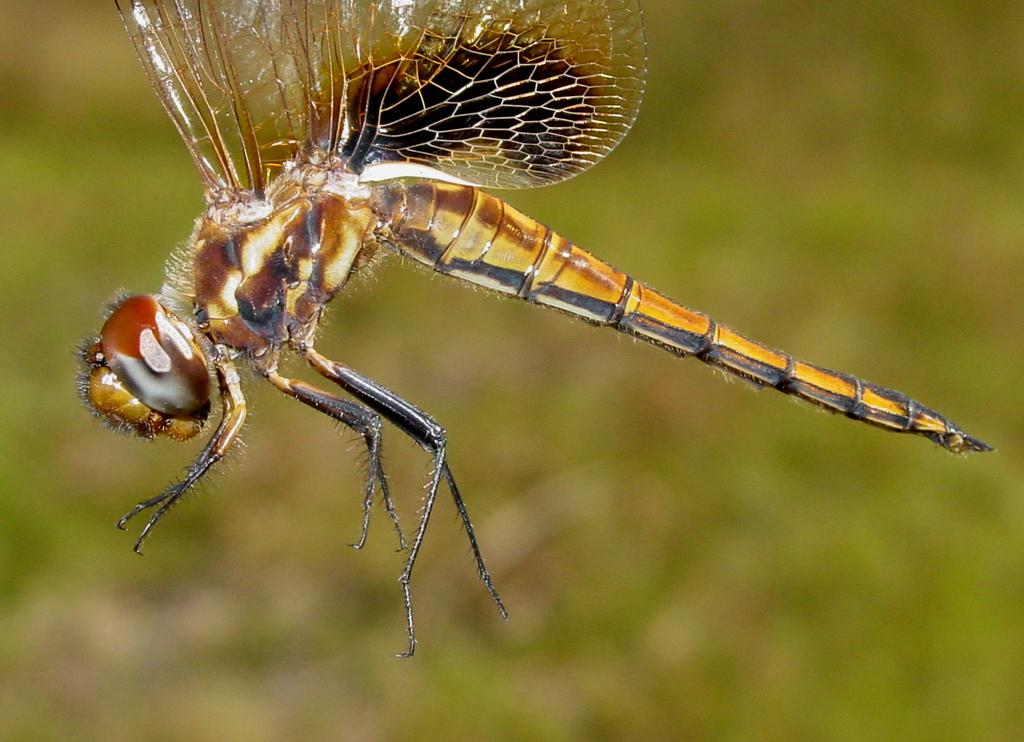What type of creature can be seen in the image? There is an insect in the image. Can you describe the background of the image? The background of the image is blurry. What type of gate is visible in the image? There is no gate present in the image; it only features an insect and a blurry background. 